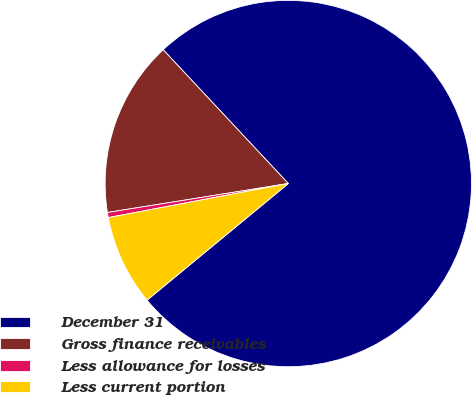Convert chart to OTSL. <chart><loc_0><loc_0><loc_500><loc_500><pie_chart><fcel>December 31<fcel>Gross finance receivables<fcel>Less allowance for losses<fcel>Less current portion<nl><fcel>75.98%<fcel>15.56%<fcel>0.45%<fcel>8.01%<nl></chart> 